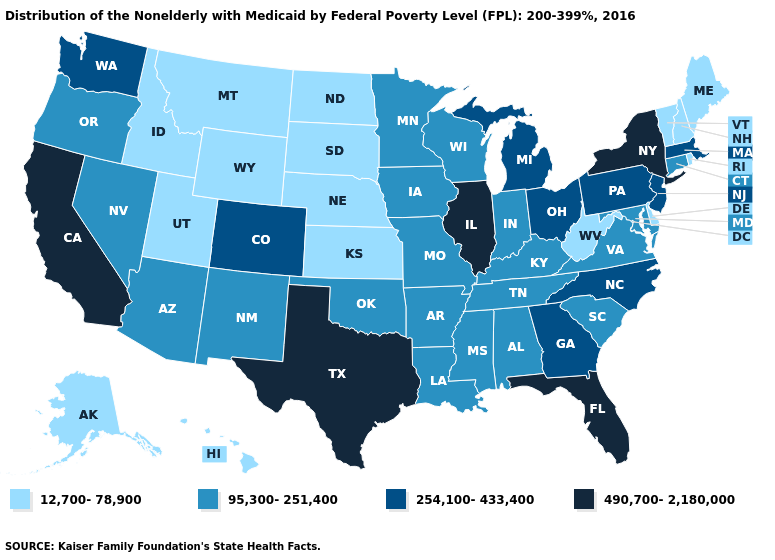Among the states that border Vermont , does New Hampshire have the lowest value?
Answer briefly. Yes. Which states have the lowest value in the USA?
Answer briefly. Alaska, Delaware, Hawaii, Idaho, Kansas, Maine, Montana, Nebraska, New Hampshire, North Dakota, Rhode Island, South Dakota, Utah, Vermont, West Virginia, Wyoming. What is the highest value in states that border New York?
Write a very short answer. 254,100-433,400. Which states have the highest value in the USA?
Be succinct. California, Florida, Illinois, New York, Texas. Does North Carolina have a lower value than Illinois?
Concise answer only. Yes. Does Nevada have a lower value than Maine?
Be succinct. No. Name the states that have a value in the range 254,100-433,400?
Answer briefly. Colorado, Georgia, Massachusetts, Michigan, New Jersey, North Carolina, Ohio, Pennsylvania, Washington. Name the states that have a value in the range 95,300-251,400?
Keep it brief. Alabama, Arizona, Arkansas, Connecticut, Indiana, Iowa, Kentucky, Louisiana, Maryland, Minnesota, Mississippi, Missouri, Nevada, New Mexico, Oklahoma, Oregon, South Carolina, Tennessee, Virginia, Wisconsin. How many symbols are there in the legend?
Write a very short answer. 4. Name the states that have a value in the range 254,100-433,400?
Give a very brief answer. Colorado, Georgia, Massachusetts, Michigan, New Jersey, North Carolina, Ohio, Pennsylvania, Washington. Name the states that have a value in the range 490,700-2,180,000?
Short answer required. California, Florida, Illinois, New York, Texas. Name the states that have a value in the range 254,100-433,400?
Quick response, please. Colorado, Georgia, Massachusetts, Michigan, New Jersey, North Carolina, Ohio, Pennsylvania, Washington. Name the states that have a value in the range 12,700-78,900?
Give a very brief answer. Alaska, Delaware, Hawaii, Idaho, Kansas, Maine, Montana, Nebraska, New Hampshire, North Dakota, Rhode Island, South Dakota, Utah, Vermont, West Virginia, Wyoming. What is the value of New Mexico?
Concise answer only. 95,300-251,400. Name the states that have a value in the range 95,300-251,400?
Answer briefly. Alabama, Arizona, Arkansas, Connecticut, Indiana, Iowa, Kentucky, Louisiana, Maryland, Minnesota, Mississippi, Missouri, Nevada, New Mexico, Oklahoma, Oregon, South Carolina, Tennessee, Virginia, Wisconsin. 